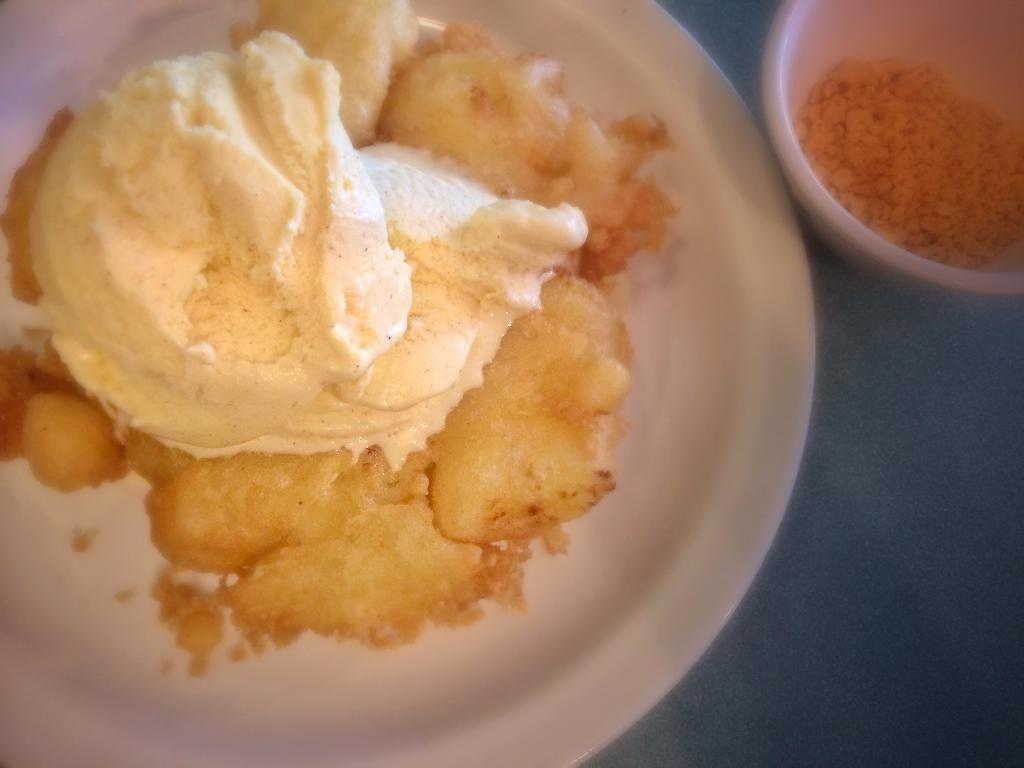What piece of furniture is present in the image? There is a table in the image. What is on the table in the image? There is a bowl of crumbles and a plate with an ice cream sandwich on the table. What statement is being made by the juice in the image? There is no juice present in the image, so no statement can be made by it. 